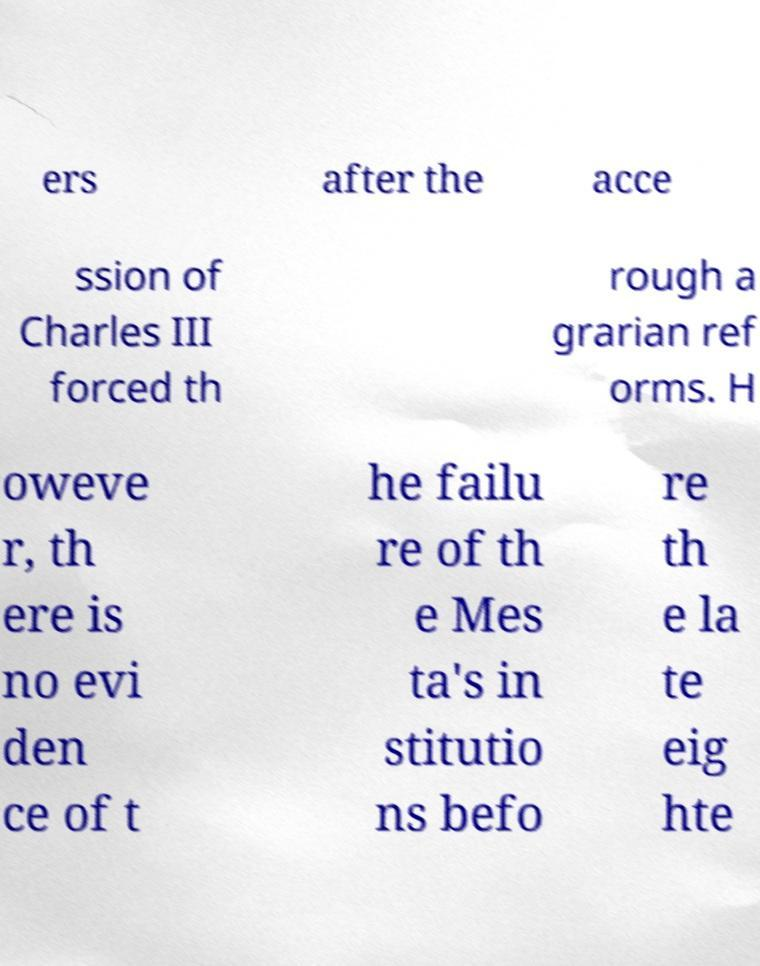Can you accurately transcribe the text from the provided image for me? ers after the acce ssion of Charles III forced th rough a grarian ref orms. H oweve r, th ere is no evi den ce of t he failu re of th e Mes ta's in stitutio ns befo re th e la te eig hte 